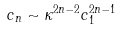<formula> <loc_0><loc_0><loc_500><loc_500>c _ { n } \sim \kappa ^ { 2 n - 2 } c _ { 1 } ^ { 2 n - 1 }</formula> 